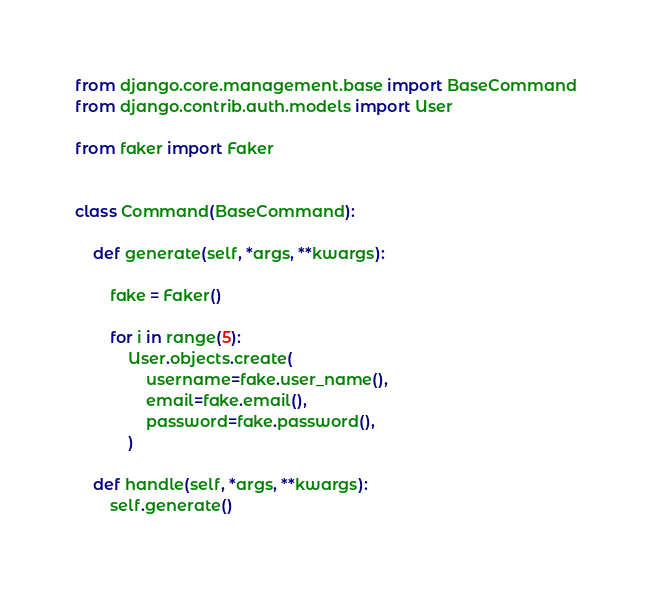Convert code to text. <code><loc_0><loc_0><loc_500><loc_500><_Python_>from django.core.management.base import BaseCommand
from django.contrib.auth.models import User

from faker import Faker


class Command(BaseCommand):

    def generate(self, *args, **kwargs):

        fake = Faker()

        for i in range(5):
            User.objects.create(
                username=fake.user_name(),
                email=fake.email(),
                password=fake.password(),
            )

    def handle(self, *args, **kwargs):
        self.generate()
</code> 